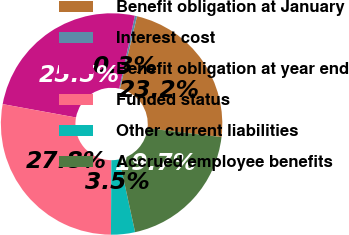Convert chart. <chart><loc_0><loc_0><loc_500><loc_500><pie_chart><fcel>Benefit obligation at January<fcel>Interest cost<fcel>Benefit obligation at year end<fcel>Funded status<fcel>Other current liabilities<fcel>Accrued employee benefits<nl><fcel>23.2%<fcel>0.32%<fcel>25.49%<fcel>27.78%<fcel>3.5%<fcel>19.71%<nl></chart> 